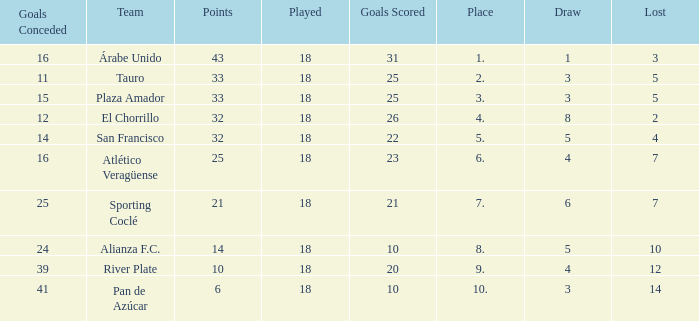How many goals were conceded by the team with more than 21 points more than 5 draws and less than 18 games played? None. 